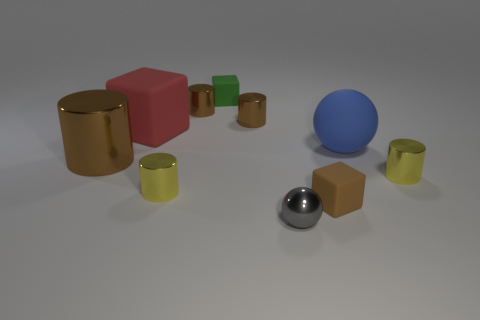How many brown cylinders must be subtracted to get 1 brown cylinders? 2 Subtract all brown cubes. How many cubes are left? 2 Subtract all purple cubes. How many brown cylinders are left? 3 Subtract 3 cylinders. How many cylinders are left? 2 Subtract all yellow cylinders. How many cylinders are left? 3 Subtract all gray cylinders. Subtract all gray blocks. How many cylinders are left? 5 Subtract 1 red blocks. How many objects are left? 9 Subtract all cubes. How many objects are left? 7 Subtract all big things. Subtract all tiny red shiny objects. How many objects are left? 7 Add 2 small green objects. How many small green objects are left? 3 